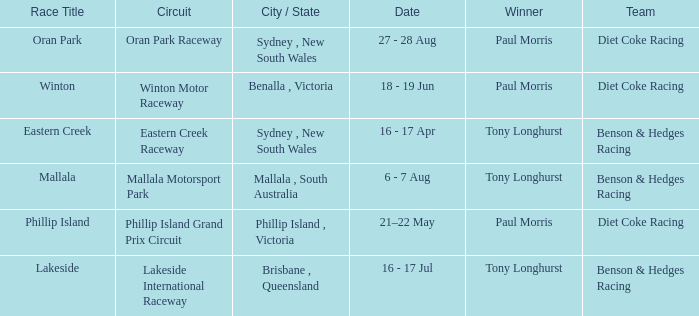What was the name of the driver that won the Lakeside race? Tony Longhurst. 